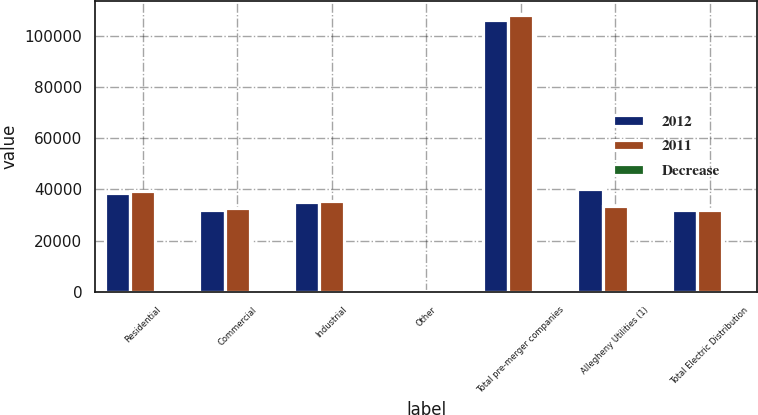Convert chart. <chart><loc_0><loc_0><loc_500><loc_500><stacked_bar_chart><ecel><fcel>Residential<fcel>Commercial<fcel>Industrial<fcel>Other<fcel>Total pre-merger companies<fcel>Allegheny Utilities (1)<fcel>Total Electric Distribution<nl><fcel>2012<fcel>38493<fcel>32149<fcel>35139<fcel>492<fcel>106273<fcel>40328<fcel>32149<nl><fcel>2011<fcel>39369<fcel>32610<fcel>35637<fcel>513<fcel>108129<fcel>33449<fcel>32149<nl><fcel>Decrease<fcel>2.2<fcel>1.4<fcel>1.4<fcel>4.1<fcel>1.7<fcel>20.6<fcel>3.5<nl></chart> 